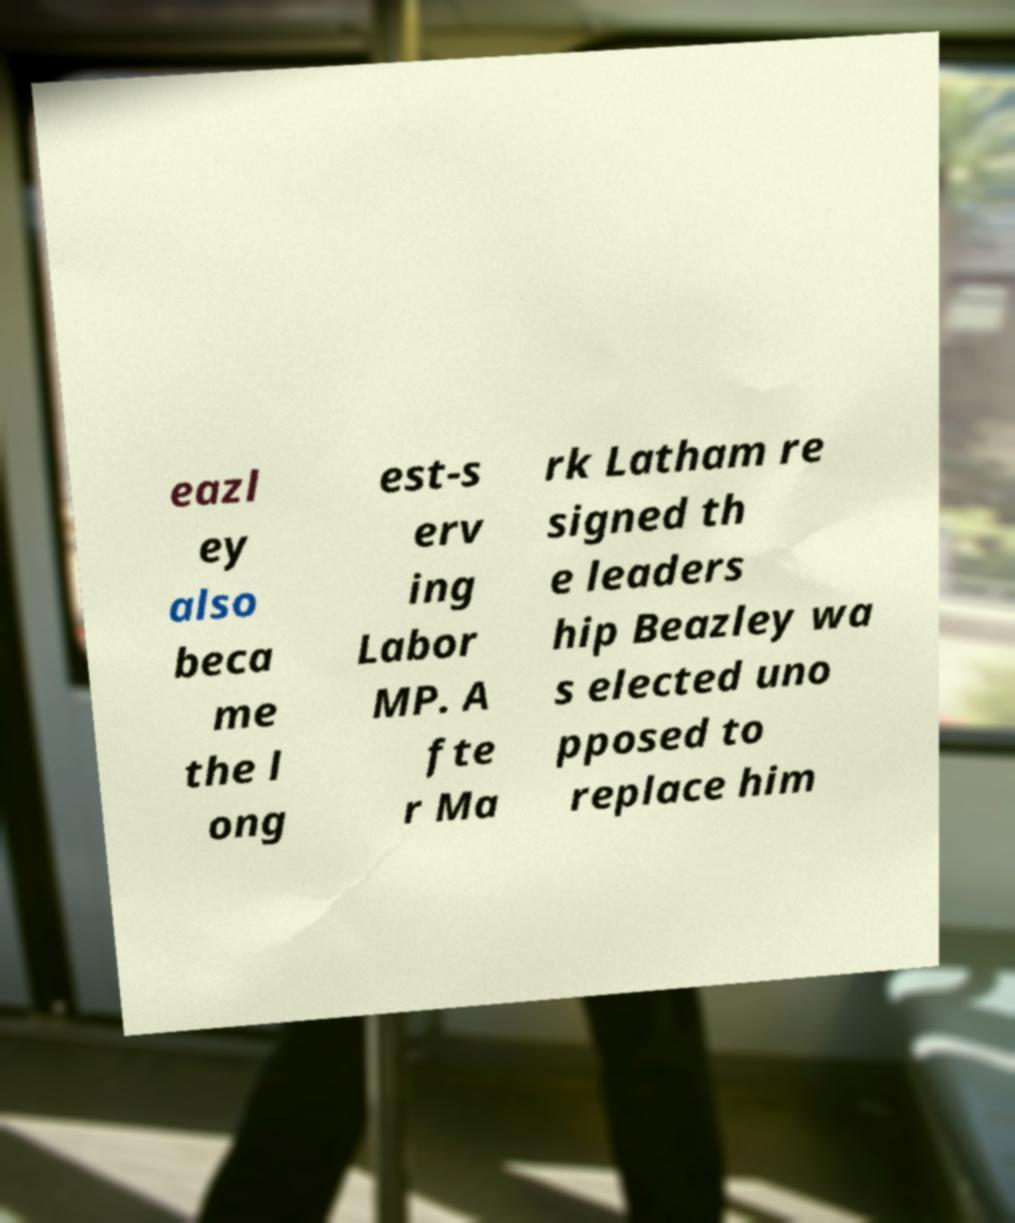Can you read and provide the text displayed in the image?This photo seems to have some interesting text. Can you extract and type it out for me? eazl ey also beca me the l ong est-s erv ing Labor MP. A fte r Ma rk Latham re signed th e leaders hip Beazley wa s elected uno pposed to replace him 